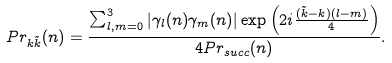Convert formula to latex. <formula><loc_0><loc_0><loc_500><loc_500>P r _ { k \tilde { k } } ( n ) = \frac { \sum _ { l , m = 0 } ^ { 3 } | \gamma _ { l } ( n ) \gamma _ { m } ( n ) | \exp \left ( 2 i \frac { ( \tilde { k } - k ) ( l - m ) } { 4 } \right ) } { 4 P r _ { s u c c } ( n ) } .</formula> 